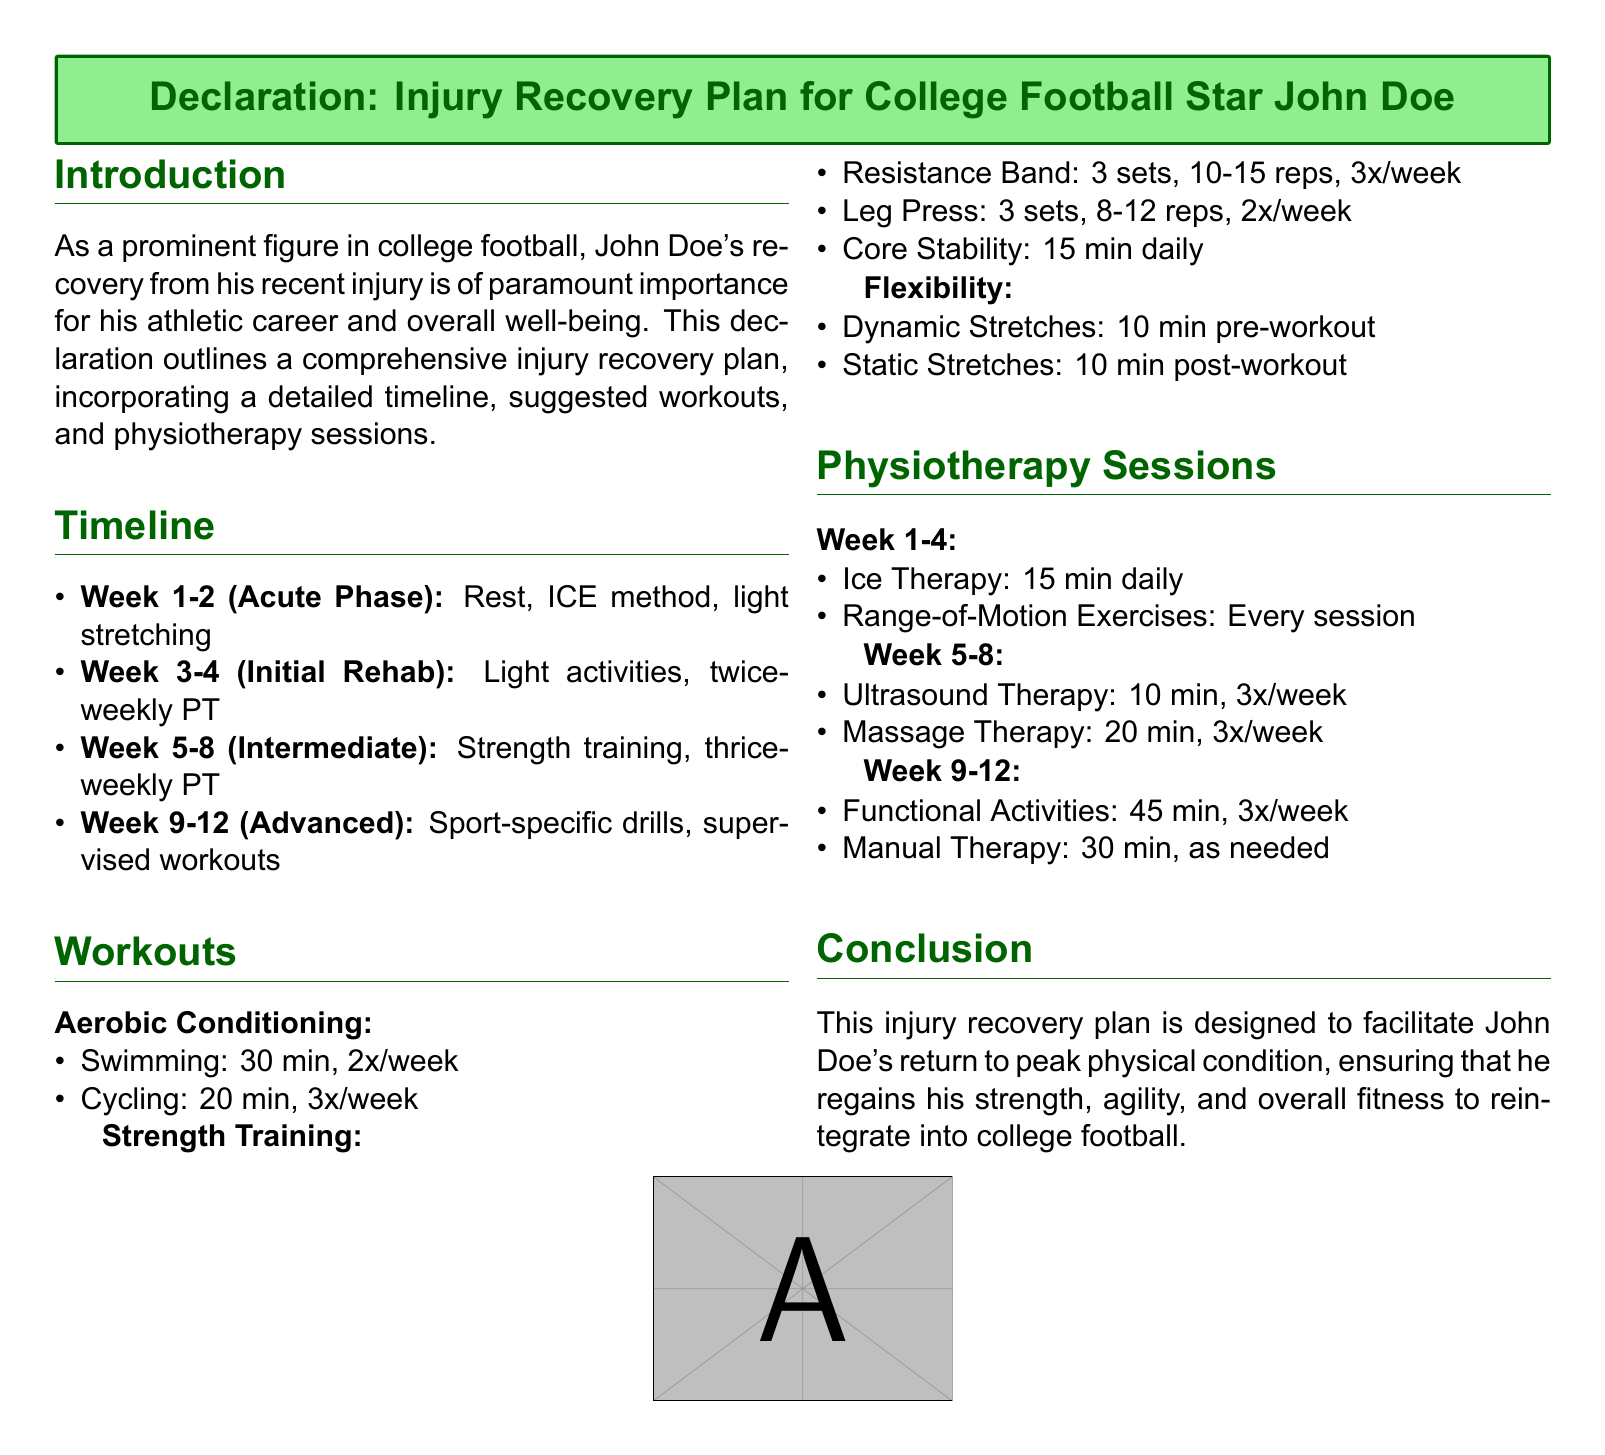What is the name of the college football star? The document specifies the name of the college football star as John Doe.
Answer: John Doe What are the primary workout types listed in the recovery plan? The recovery plan outlines three primary workout types: Aerobic Conditioning, Strength Training, and Flexibility.
Answer: Aerobic Conditioning, Strength Training, Flexibility How many weeks are allocated for the acute phase of recovery? The timeline indicates the acute phase lasts for 2 weeks.
Answer: 2 weeks What therapy is scheduled for week 5-8? The document includes Ultrasound Therapy and Massage Therapy during week 5-8.
Answer: Ultrasound Therapy and Massage Therapy How often will strength training occur during the recovery plan? The recovery plan details that strength training occurs three times a week.
Answer: 3 times a week What is the duration of the manual therapy sessions? The document states the duration of manual therapy sessions is 30 minutes, as needed.
Answer: 30 minutes What type of therapy is suggested daily in the first four weeks? The plan includes Ice Therapy as a daily suggestion in the first four weeks.
Answer: Ice Therapy Which exercise is included for Aerobic Conditioning? The document lists Swimming and Cycling as the exercises for Aerobic Conditioning.
Answer: Swimming and Cycling What is the purpose of the injury recovery plan? The document outlines the purpose of the plan as facilitating John Doe's return to peak physical condition.
Answer: Facilitating return to peak physical condition 